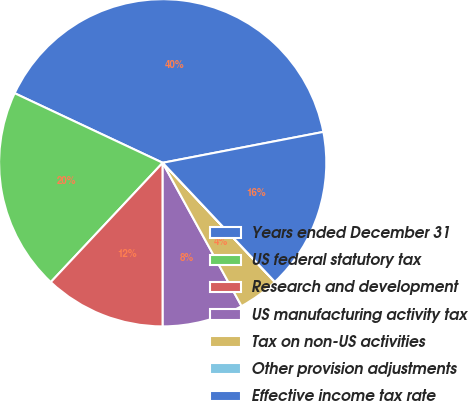Convert chart. <chart><loc_0><loc_0><loc_500><loc_500><pie_chart><fcel>Years ended December 31<fcel>US federal statutory tax<fcel>Research and development<fcel>US manufacturing activity tax<fcel>Tax on non-US activities<fcel>Other provision adjustments<fcel>Effective income tax rate<nl><fcel>39.99%<fcel>20.0%<fcel>12.0%<fcel>8.0%<fcel>4.01%<fcel>0.01%<fcel>16.0%<nl></chart> 